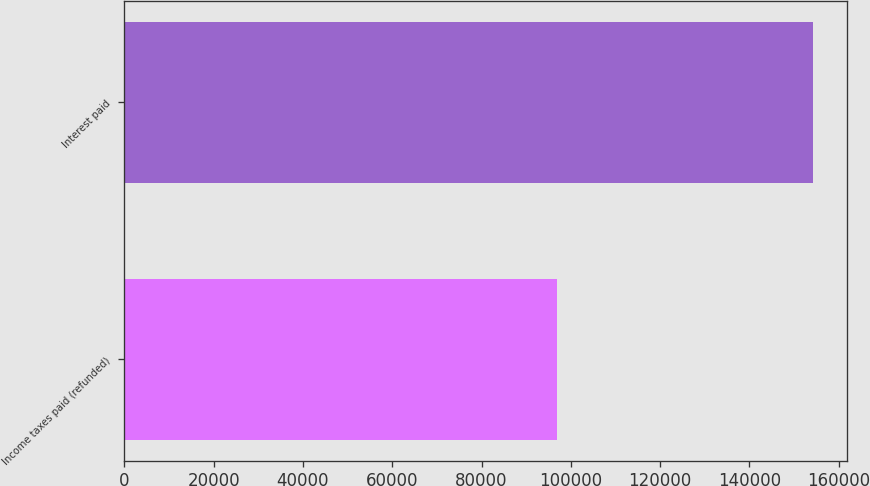Convert chart. <chart><loc_0><loc_0><loc_500><loc_500><bar_chart><fcel>Income taxes paid (refunded)<fcel>Interest paid<nl><fcel>97002<fcel>154200<nl></chart> 